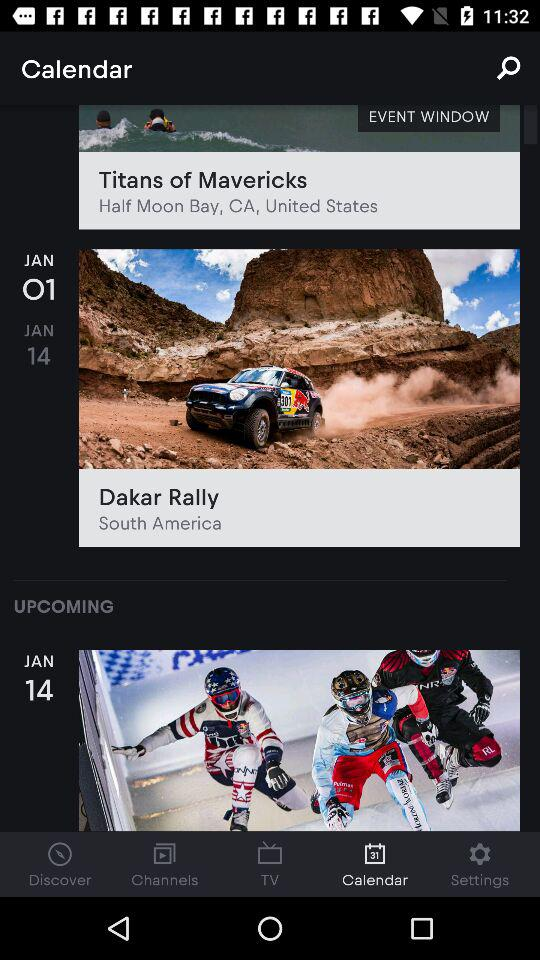How many events are in the calendar?
Answer the question using a single word or phrase. 3 